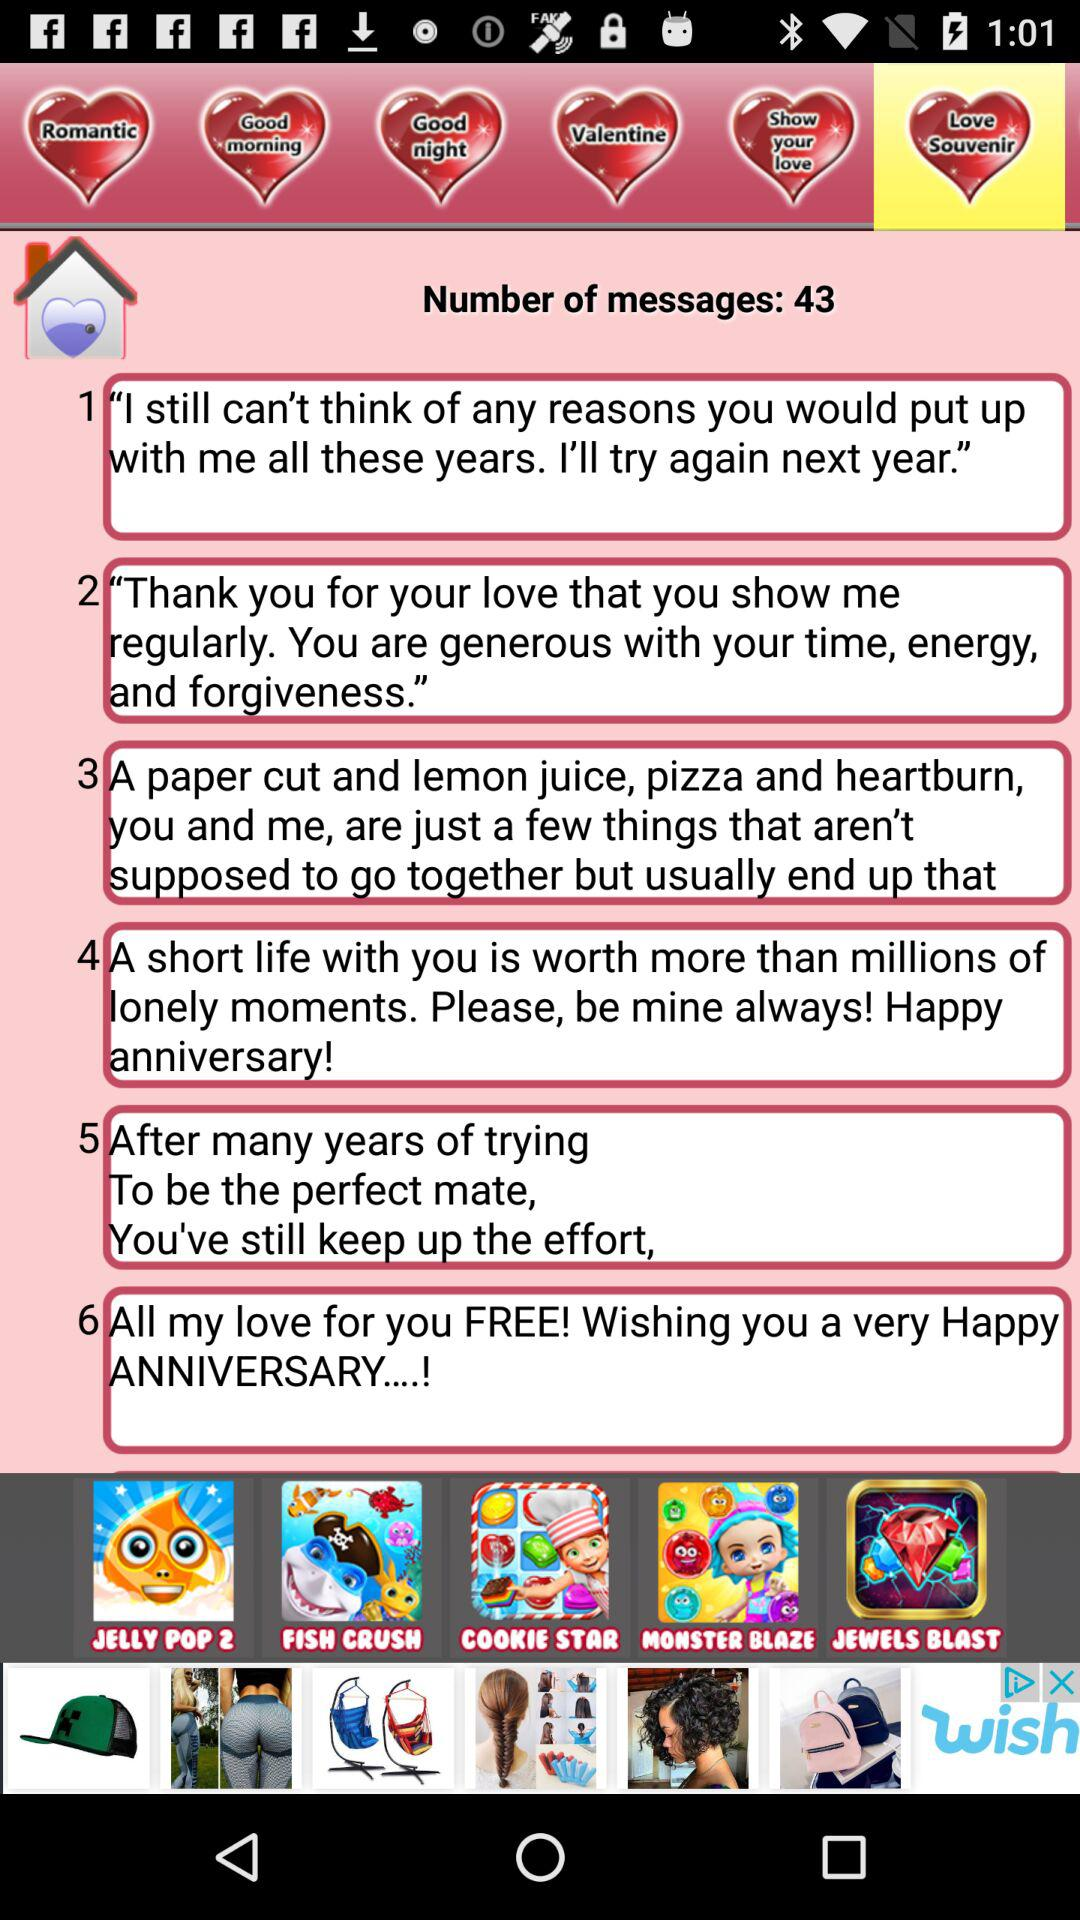How many messages are there?
Answer the question using a single word or phrase. 43 